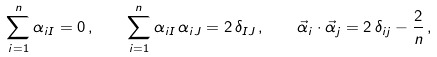Convert formula to latex. <formula><loc_0><loc_0><loc_500><loc_500>\sum _ { i = 1 } ^ { n } \alpha _ { i I } = 0 \, , \quad \sum _ { i = 1 } ^ { n } \alpha _ { i I } \, \alpha _ { i J } = 2 \, \delta _ { I J } \, , \quad \vec { \alpha } _ { i } \cdot \vec { \alpha } _ { j } = 2 \, \delta _ { i j } - \frac { 2 } { n } \, ,</formula> 